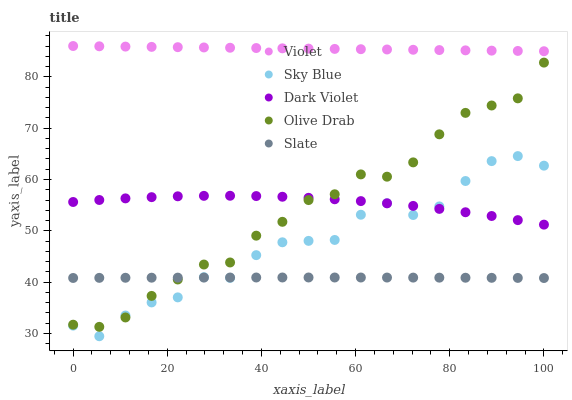Does Slate have the minimum area under the curve?
Answer yes or no. Yes. Does Violet have the maximum area under the curve?
Answer yes or no. Yes. Does Olive Drab have the minimum area under the curve?
Answer yes or no. No. Does Olive Drab have the maximum area under the curve?
Answer yes or no. No. Is Violet the smoothest?
Answer yes or no. Yes. Is Sky Blue the roughest?
Answer yes or no. Yes. Is Slate the smoothest?
Answer yes or no. No. Is Slate the roughest?
Answer yes or no. No. Does Sky Blue have the lowest value?
Answer yes or no. Yes. Does Slate have the lowest value?
Answer yes or no. No. Does Violet have the highest value?
Answer yes or no. Yes. Does Olive Drab have the highest value?
Answer yes or no. No. Is Slate less than Violet?
Answer yes or no. Yes. Is Violet greater than Dark Violet?
Answer yes or no. Yes. Does Dark Violet intersect Sky Blue?
Answer yes or no. Yes. Is Dark Violet less than Sky Blue?
Answer yes or no. No. Is Dark Violet greater than Sky Blue?
Answer yes or no. No. Does Slate intersect Violet?
Answer yes or no. No. 